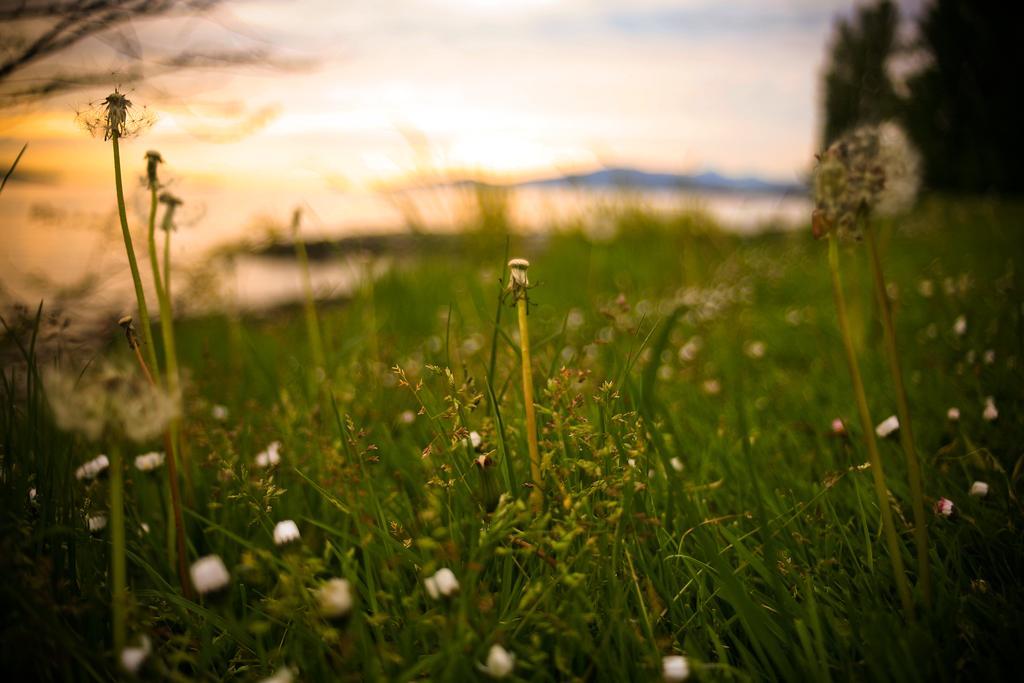Could you give a brief overview of what you see in this image? In this image, these look like the plants with the tiny flowers. The background looks blurry. I think these are the trees. 